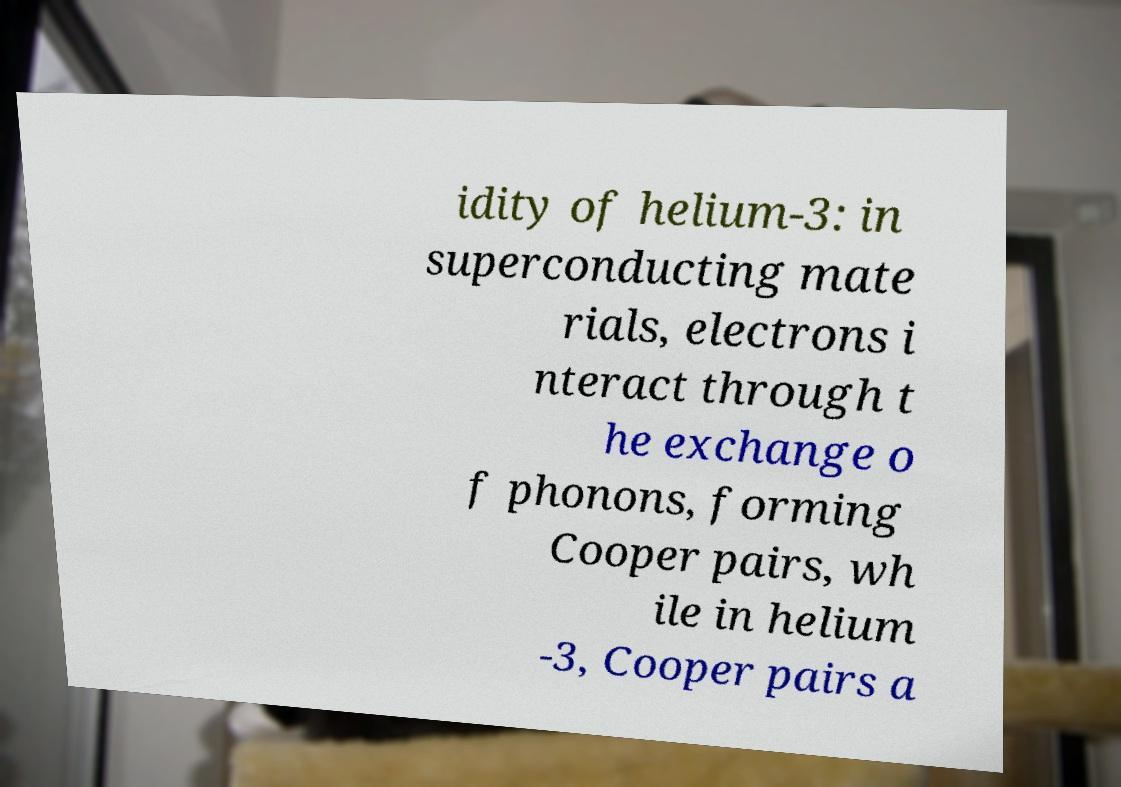Please identify and transcribe the text found in this image. idity of helium-3: in superconducting mate rials, electrons i nteract through t he exchange o f phonons, forming Cooper pairs, wh ile in helium -3, Cooper pairs a 